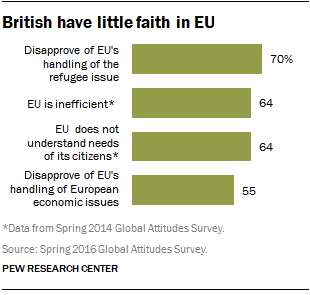Draw attention to some important aspects in this diagram. The average of the highest and lowest bars is 62.5. There are four categories in the chart. 